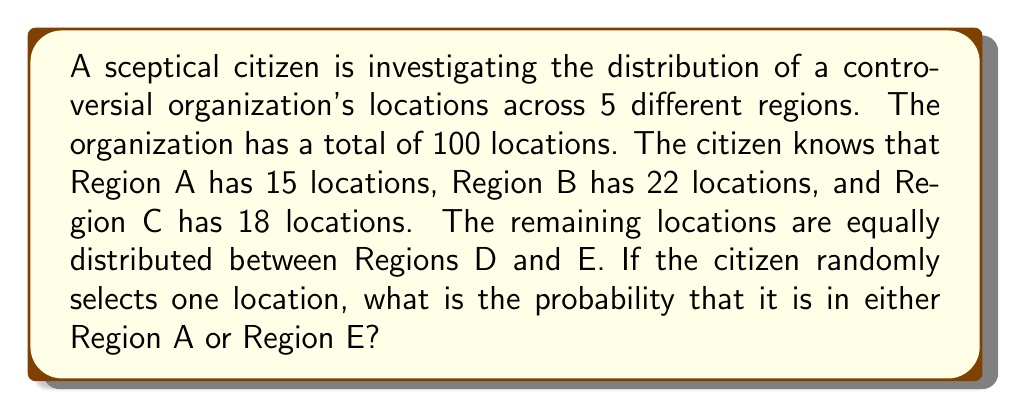Teach me how to tackle this problem. Let's approach this step-by-step:

1) First, we need to determine how many locations are in Regions D and E combined:
   $$100 - (15 + 22 + 18) = 100 - 55 = 45$$

2) Since the remaining locations are equally distributed between Regions D and E, each of these regions has:
   $$45 \div 2 = 22.5$$ locations

3) Now we know the distribution across all regions:
   Region A: 15
   Region B: 22
   Region C: 18
   Region D: 22.5
   Region E: 22.5

4) The question asks for the probability of selecting a location in either Region A or Region E. To calculate this, we need to add the number of locations in these two regions and divide by the total number of locations:

   $$P(\text{A or E}) = \frac{\text{Locations in A} + \text{Locations in E}}{\text{Total Locations}}$$

   $$P(\text{A or E}) = \frac{15 + 22.5}{100} = \frac{37.5}{100} = 0.375$$

5) This can be expressed as a fraction by multiplying both numerator and denominator by 8:

   $$\frac{37.5}{100} = \frac{37.5 \times 8}{100 \times 8} = \frac{300}{800} = \frac{3}{8}$$
Answer: $\frac{3}{8}$ or 0.375 or 37.5% 